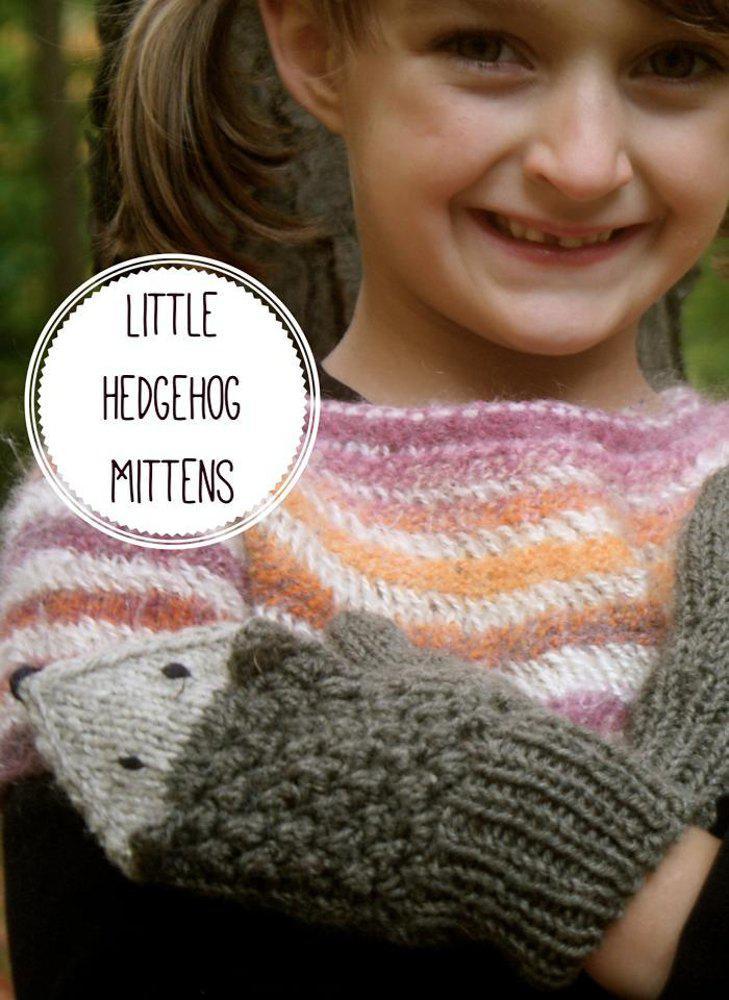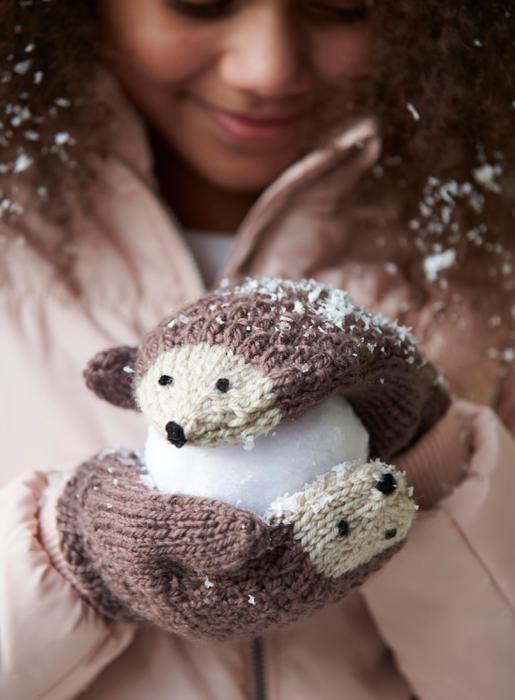The first image is the image on the left, the second image is the image on the right. Examine the images to the left and right. Is the description "human hands are visible" accurate? Answer yes or no. No. 